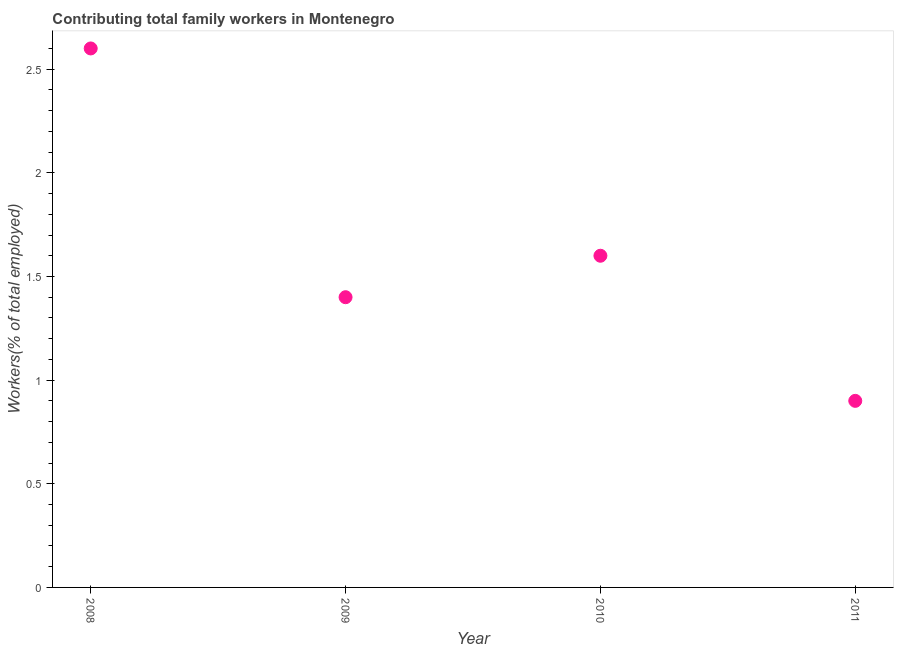What is the contributing family workers in 2010?
Your response must be concise. 1.6. Across all years, what is the maximum contributing family workers?
Provide a short and direct response. 2.6. Across all years, what is the minimum contributing family workers?
Your answer should be very brief. 0.9. In which year was the contributing family workers maximum?
Offer a terse response. 2008. What is the sum of the contributing family workers?
Your response must be concise. 6.5. What is the difference between the contributing family workers in 2009 and 2010?
Your response must be concise. -0.2. What is the average contributing family workers per year?
Make the answer very short. 1.62. What is the median contributing family workers?
Ensure brevity in your answer.  1.5. What is the ratio of the contributing family workers in 2009 to that in 2010?
Your answer should be very brief. 0.87. What is the difference between the highest and the second highest contributing family workers?
Your answer should be very brief. 1. Is the sum of the contributing family workers in 2008 and 2010 greater than the maximum contributing family workers across all years?
Ensure brevity in your answer.  Yes. What is the difference between the highest and the lowest contributing family workers?
Keep it short and to the point. 1.7. Does the contributing family workers monotonically increase over the years?
Your answer should be very brief. No. How many dotlines are there?
Ensure brevity in your answer.  1. How many years are there in the graph?
Ensure brevity in your answer.  4. Does the graph contain any zero values?
Provide a succinct answer. No. What is the title of the graph?
Keep it short and to the point. Contributing total family workers in Montenegro. What is the label or title of the Y-axis?
Your response must be concise. Workers(% of total employed). What is the Workers(% of total employed) in 2008?
Give a very brief answer. 2.6. What is the Workers(% of total employed) in 2009?
Make the answer very short. 1.4. What is the Workers(% of total employed) in 2010?
Your answer should be compact. 1.6. What is the Workers(% of total employed) in 2011?
Keep it short and to the point. 0.9. What is the difference between the Workers(% of total employed) in 2008 and 2011?
Keep it short and to the point. 1.7. What is the difference between the Workers(% of total employed) in 2009 and 2010?
Offer a very short reply. -0.2. What is the ratio of the Workers(% of total employed) in 2008 to that in 2009?
Your answer should be compact. 1.86. What is the ratio of the Workers(% of total employed) in 2008 to that in 2010?
Your response must be concise. 1.62. What is the ratio of the Workers(% of total employed) in 2008 to that in 2011?
Give a very brief answer. 2.89. What is the ratio of the Workers(% of total employed) in 2009 to that in 2011?
Your answer should be very brief. 1.56. What is the ratio of the Workers(% of total employed) in 2010 to that in 2011?
Keep it short and to the point. 1.78. 